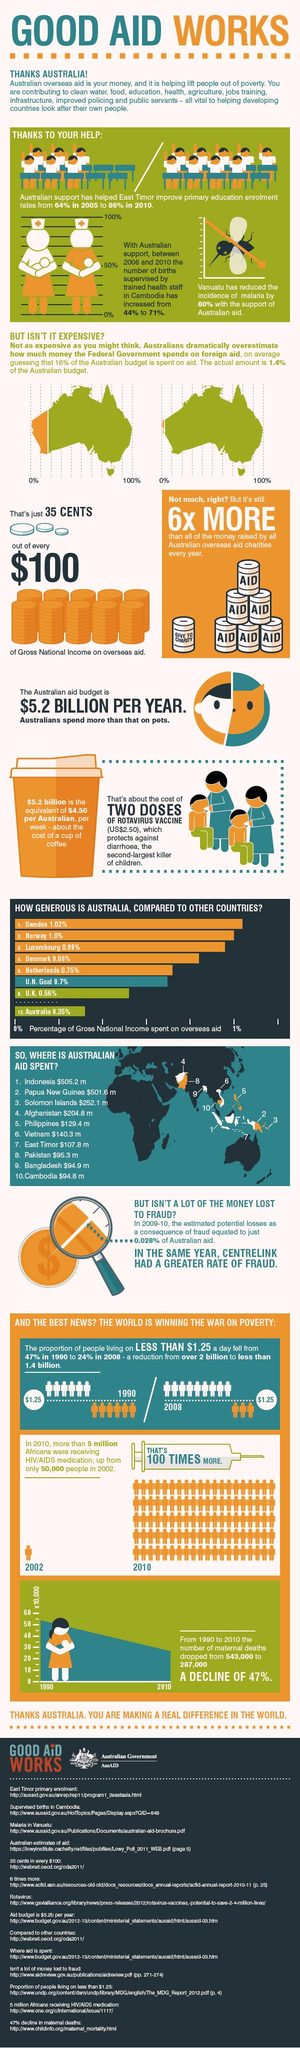List a handful of essential elements in this visual. The number of births supervised by trained health staff in Cambodia increased by 27% between 2006 and 2010. In the year 2020, Norway and Australia together spent 1.35% of their Gross National Income on overseas aid. According to the given information, the combined percentage of Gross National Income spent on overseas aid by Sweden and Norway is 2.02%. Denmark and the Netherlands, taken together, spend 1.61% of their Gross National Income on overseas aid. 